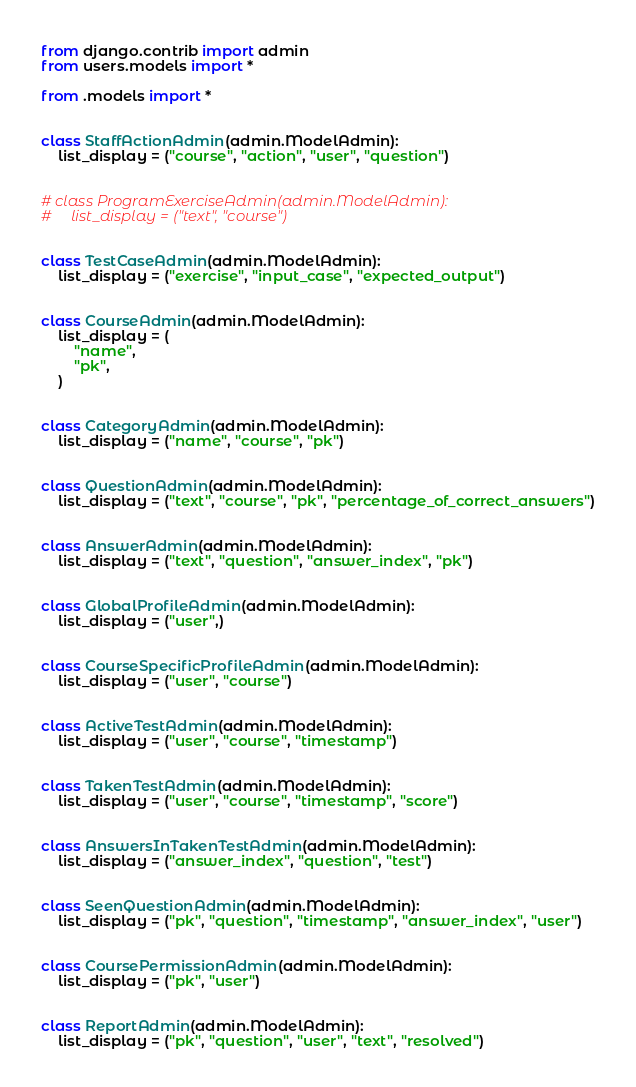Convert code to text. <code><loc_0><loc_0><loc_500><loc_500><_Python_>from django.contrib import admin
from users.models import *

from .models import *


class StaffActionAdmin(admin.ModelAdmin):
    list_display = ("course", "action", "user", "question")


# class ProgramExerciseAdmin(admin.ModelAdmin):
#     list_display = ("text", "course")


class TestCaseAdmin(admin.ModelAdmin):
    list_display = ("exercise", "input_case", "expected_output")


class CourseAdmin(admin.ModelAdmin):
    list_display = (
        "name",
        "pk",
    )


class CategoryAdmin(admin.ModelAdmin):
    list_display = ("name", "course", "pk")


class QuestionAdmin(admin.ModelAdmin):
    list_display = ("text", "course", "pk", "percentage_of_correct_answers")


class AnswerAdmin(admin.ModelAdmin):
    list_display = ("text", "question", "answer_index", "pk")


class GlobalProfileAdmin(admin.ModelAdmin):
    list_display = ("user",)


class CourseSpecificProfileAdmin(admin.ModelAdmin):
    list_display = ("user", "course")


class ActiveTestAdmin(admin.ModelAdmin):
    list_display = ("user", "course", "timestamp")


class TakenTestAdmin(admin.ModelAdmin):
    list_display = ("user", "course", "timestamp", "score")


class AnswersInTakenTestAdmin(admin.ModelAdmin):
    list_display = ("answer_index", "question", "test")


class SeenQuestionAdmin(admin.ModelAdmin):
    list_display = ("pk", "question", "timestamp", "answer_index", "user")


class CoursePermissionAdmin(admin.ModelAdmin):
    list_display = ("pk", "user")


class ReportAdmin(admin.ModelAdmin):
    list_display = ("pk", "question", "user", "text", "resolved")

</code> 